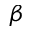<formula> <loc_0><loc_0><loc_500><loc_500>\beta</formula> 